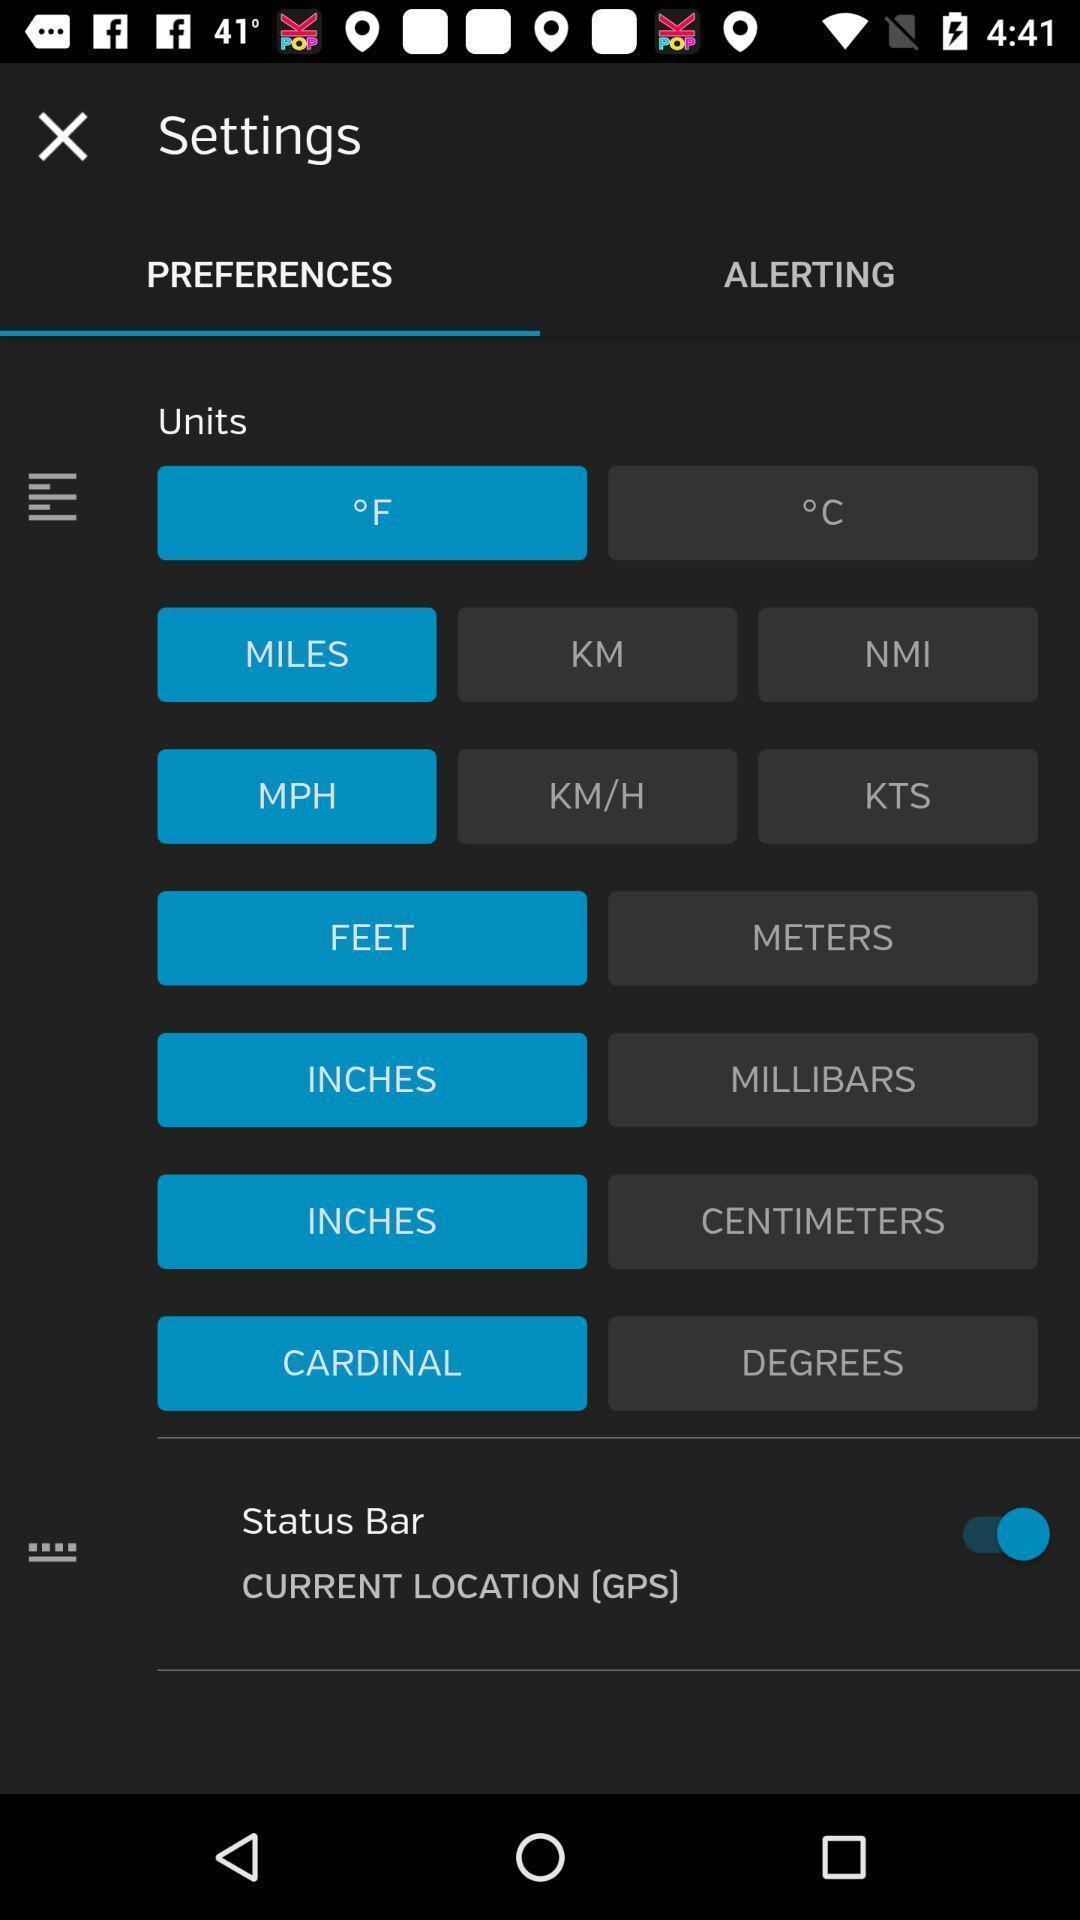Explain what's happening in this screen capture. Settings page of a car care app. 